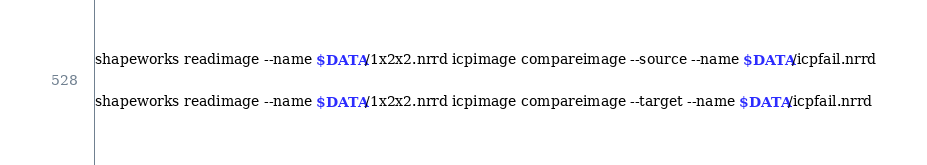<code> <loc_0><loc_0><loc_500><loc_500><_Bash_>
shapeworks readimage --name $DATA/1x2x2.nrrd icpimage compareimage --source --name $DATA/icpfail.nrrd

shapeworks readimage --name $DATA/1x2x2.nrrd icpimage compareimage --target --name $DATA/icpfail.nrrd
</code> 